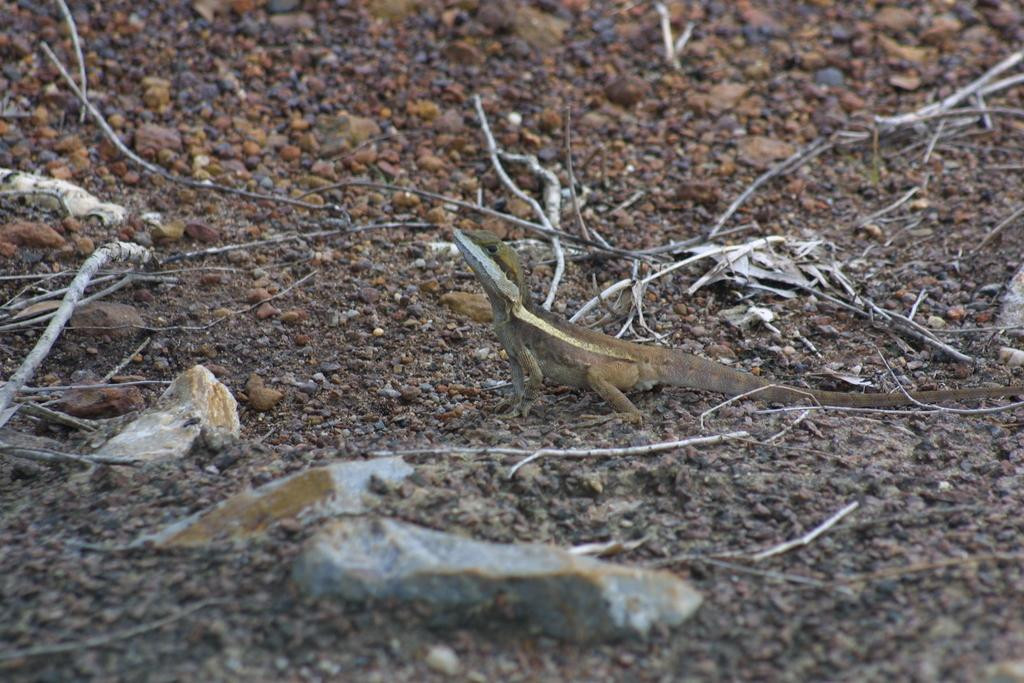What type of animal is in the image? There is a reptile in the image. Can you describe the color pattern of the reptile? The reptile has brown and cream colors. What can be seen in the background of the image? There are brown-colored stones in the background of the image. What type of ghost is haunting the reptile in the image? There is no ghost present in the image; it features a reptile with brown and cream colors and brown-colored stones in the background. 